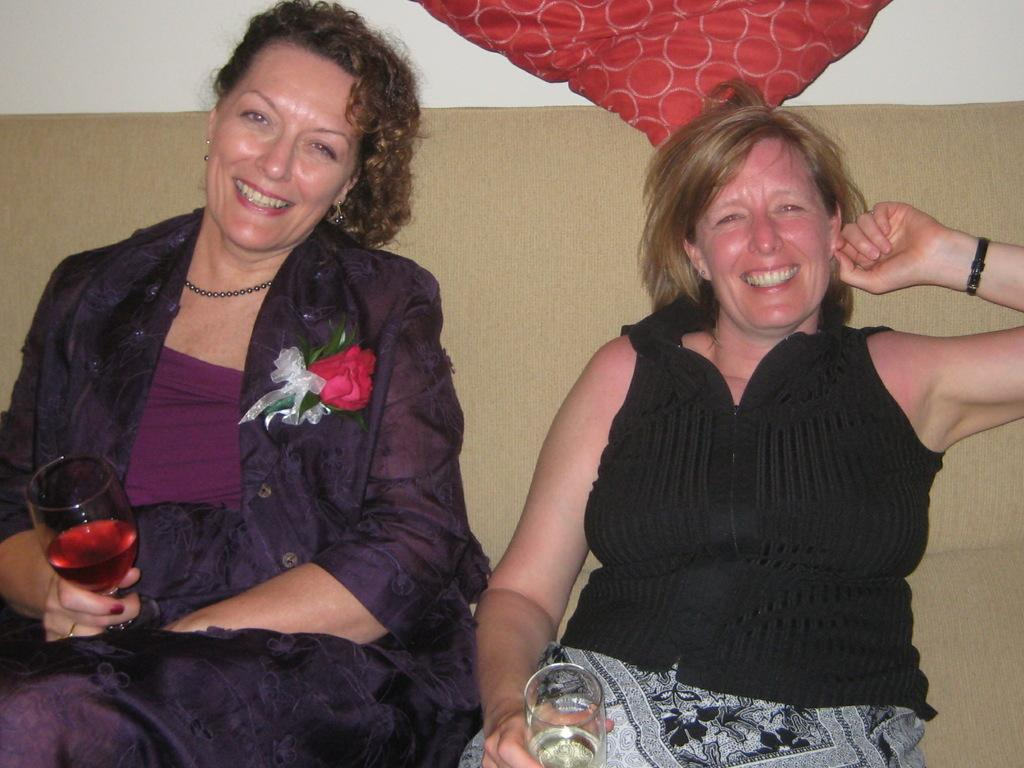How many women are in the image? There are two women in the image. What are the women doing in the image? Both women are sitting on a couch. What is one of the women holding in the image? One woman is holding a glass with liquid. What is the facial expression of the women in the image? Both women are smiling. What is the color of the dress worn by one of the women? One woman is wearing a black dress. What type of accessory is present on the jacket of the woman wearing the black dress? There is a flower on the jacket of the woman wearing the black dress. What type of substance is being served in the pie in the image? There is no pie present in the image. 